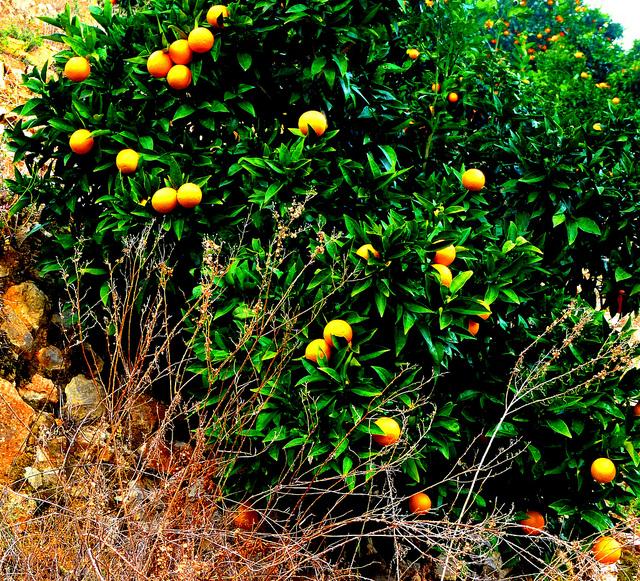Are there any animals shown?
Concise answer only. No. What grows in the tree?
Answer briefly. Oranges. What type of tree is that?
Answer briefly. Orange. 